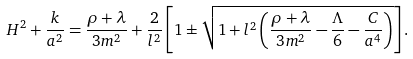<formula> <loc_0><loc_0><loc_500><loc_500>H ^ { 2 } + \frac { k } { a ^ { 2 } } = \frac { \rho + \lambda } { 3 m ^ { 2 } } + \frac { 2 } { l ^ { 2 } } \left [ 1 \pm \sqrt { 1 + l ^ { 2 } \left ( \frac { \rho + \lambda } { 3 m ^ { 2 } } - \frac { \Lambda } { 6 } - \frac { C } { a ^ { 4 } } \right ) } \right ] .</formula> 